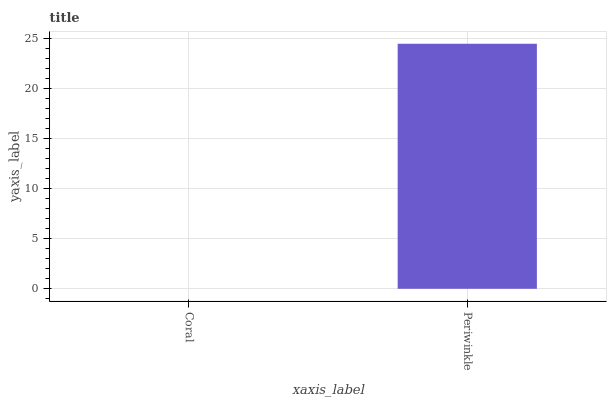Is Periwinkle the minimum?
Answer yes or no. No. Is Periwinkle greater than Coral?
Answer yes or no. Yes. Is Coral less than Periwinkle?
Answer yes or no. Yes. Is Coral greater than Periwinkle?
Answer yes or no. No. Is Periwinkle less than Coral?
Answer yes or no. No. Is Periwinkle the high median?
Answer yes or no. Yes. Is Coral the low median?
Answer yes or no. Yes. Is Coral the high median?
Answer yes or no. No. Is Periwinkle the low median?
Answer yes or no. No. 